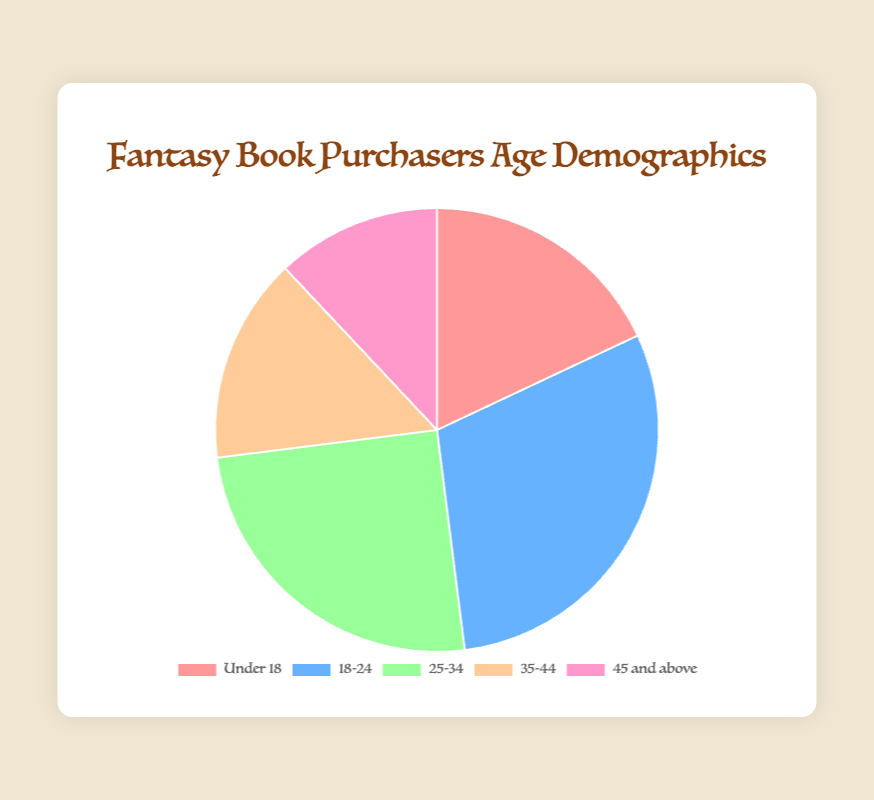Which age group has the highest percentage of fantasy book purchasers? By looking at the pie chart, the age group with the largest slice represents the highest percentage. From the data, the '18-24' age group has the highest percentage at 30%.
Answer: 18-24 Which age group has the lowest percentage of fantasy book purchasers? By identifying the smallest slice of the pie chart, we see that the '45 and above' age group has the lowest percentage at 12%.
Answer: 45 and above What is the combined percentage of fantasy book purchasers aged 25-34 and 35-44? Sum the percentages of the '25-34' age group (25%) and '35-44' age group (15%). The combined percentage is 25% + 15% = 40%.
Answer: 40% How much higher is the percentage of the 18-24 age group compared to the 35-44 age group? Subtract the percentage of the '35-44' age group (15%) from the '18-24' age group (30%). The difference is 30% - 15% = 15%.
Answer: 15% Which color represents the 'Under 18' age group in the pie chart? By referring to the legend of the pie chart, the 'Under 18' age group is represented by the color pink (it matches the label 'Under 18' with the slice color).
Answer: Pink What is the average percentage of fantasy book purchasers across all age groups? Sum all the percentages (18% + 30% + 25% + 15% + 12% = 100%) and divide it by the number of age groups (5). The average percentage is 100% / 5 = 20%.
Answer: 20% Are there more fantasy book purchasers in the '25-34' age group or in the 'Under 18' age group? By comparing the two percentages, '25-34' age group has 25% whereas 'Under 18' has 18%. Since 25% is greater than 18%, the '25-34' age group has more purchasers.
Answer: 25-34 If you combine the percentages of purchasers under 25 years old, what proportion of your customers do they represent? Sum the percentages of the 'Under 18' age group (18%) and '18-24' age group (30%). The combined percentage is 18% + 30% = 48%.
Answer: 48% How many percentage points higher is the '18-24' age group compared to the '45 and above' age group? Subtract the percentage of the '45 and above' age group (12%) from the '18-24' age group (30%). The difference is 30% - 12% = 18 percentage points.
Answer: 18 percentage points 